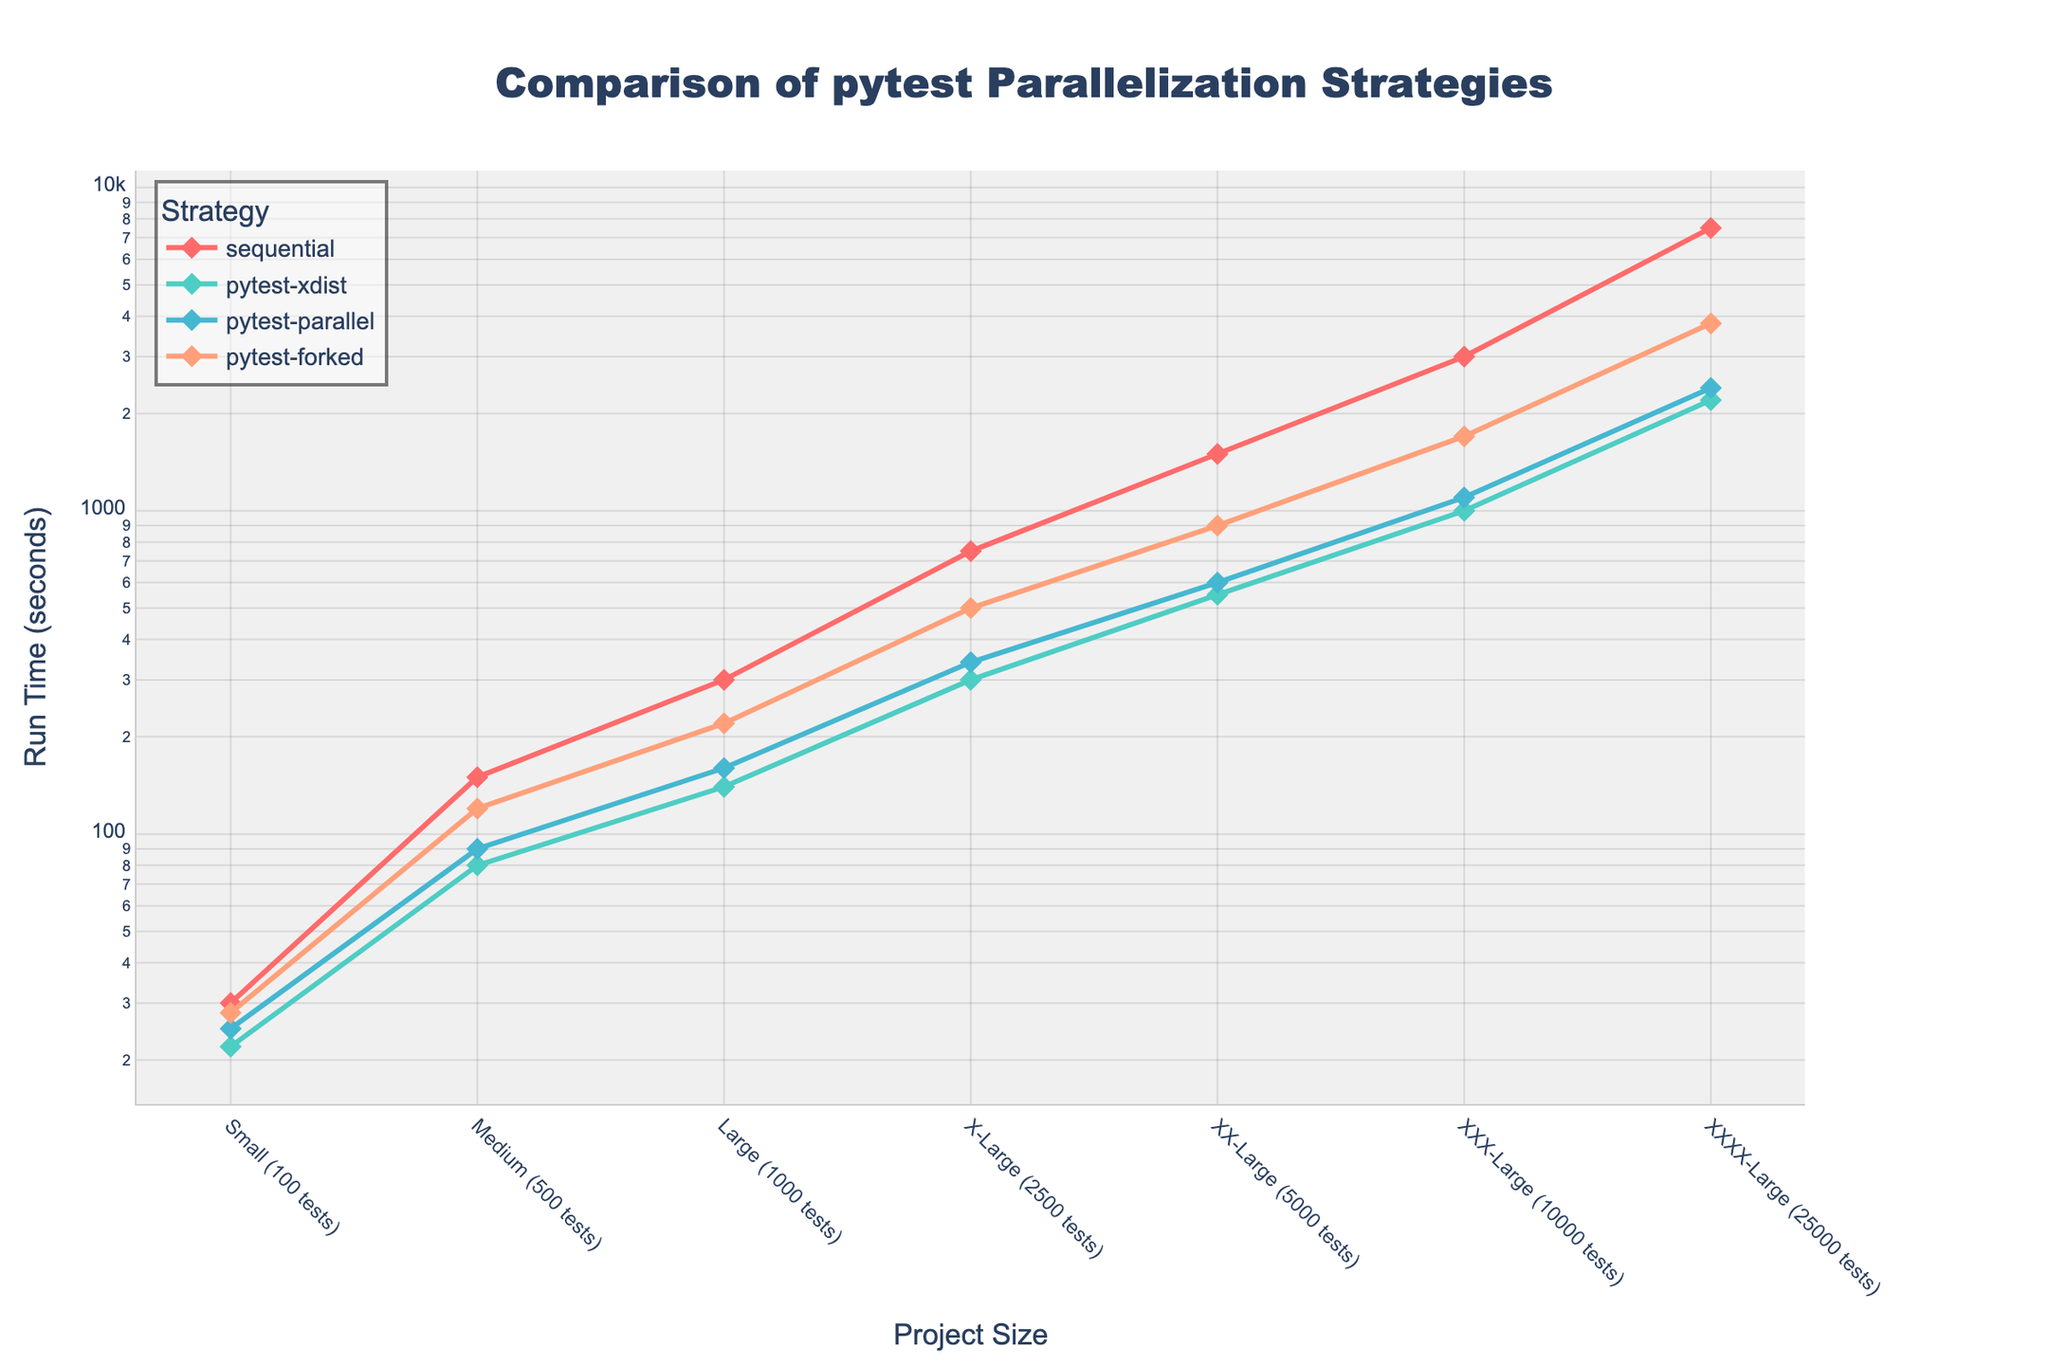How does the run time of `pytest-xdist` compare to the `sequential` strategy for the `XXX-Large (10000 tests)` project size? Compare the run times for `XXX-Large (10000 tests)` on the y-axis for both `pytest-xdist` and `sequential`. The `pytest-xdist` strategy takes 1000 seconds, while the `sequential` strategy takes 3000 seconds.
Answer: `pytest-xdist` is faster by 2000 seconds Which strategy has the shortest run time for the `Medium (500 tests)` project size? Look at the y-axis values for all strategies under `Medium (500 tests)`. `pytest-xdist` has the shortest run time at 80 seconds.
Answer: `pytest-xdist` What is the difference in run time between `pytest-parallel` and `pytest-forked` for the `X-Large (2500 tests)` project size? Compare the run times for `X-Large (2500 tests)` on the y-axis for both `pytest-parallel` and `pytest-forked`. `pytest-parallel` takes 340 seconds and `pytest-forked` takes 500 seconds. The difference is 500 - 340 = 160 seconds.
Answer: 160 seconds Between `sequential` and `pytest-forked`, which strategy performs better for the `Large (1000 tests)` project size and by how much? Compare the run times for the `Large (1000 tests)` size. `sequential` takes 300 seconds, and `pytest-forked` takes 220 seconds. `pytest-forked` performs better by 300 - 220 = 80 seconds.
Answer: `pytest-forked` by 80 seconds For the `Small (100 tests)` project size, which strategy runs tests slower, and what is the run time? Compare the y-axis values for all strategies under `Small (100 tests)`. The `sequential` strategy is the slowest at 30 seconds.
Answer: `sequential`, 30 seconds What is the average run time for all strategies for the `XX-Large (5000 tests)` project size? Calculate the average of all strategies for `XX-Large (5000 tests)`. The values are 1500 (sequential), 550 (pytest-xdist), 600 (pytest-parallel), and 900 (pytest-forked). The average is (1500 + 550 + 600 + 900) / 4 = 887.5 seconds.
Answer: 887.5 seconds Among the listed project sizes, does `sequential` ever have the shortest run time? Review the run times for all project sizes. `Sequential` does not have the shortest run time in any of the sizes.
Answer: No For the `XXXX-Large (25000 tests)` project size, what is the sum of the run times for all strategies? Add up all the run times for `XXXX-Large (25000 tests)`. The values are 7500 (sequential), 2200 (pytest-xdist), 2400 (pytest-parallel), and 3800 (pytest-forked). The sum is 7500 + 2200 + 2400 + 3800 = 15900 seconds.
Answer: 15900 seconds Compare the rate of increase in run time for `pytest-xdist` and `pytest-parallel` from `Large (1000 tests)` to `XX-Large (5000 tests)`. Which has a higher rate of increase? Calculate the increase in run time for both strategies. For `pytest-xdist`: 550 - 140 = 410 seconds. For `pytest-parallel`: 600 - 160 = 440 seconds. `pytest-parallel` has a higher rate of increase.
Answer: `pytest-parallel` 